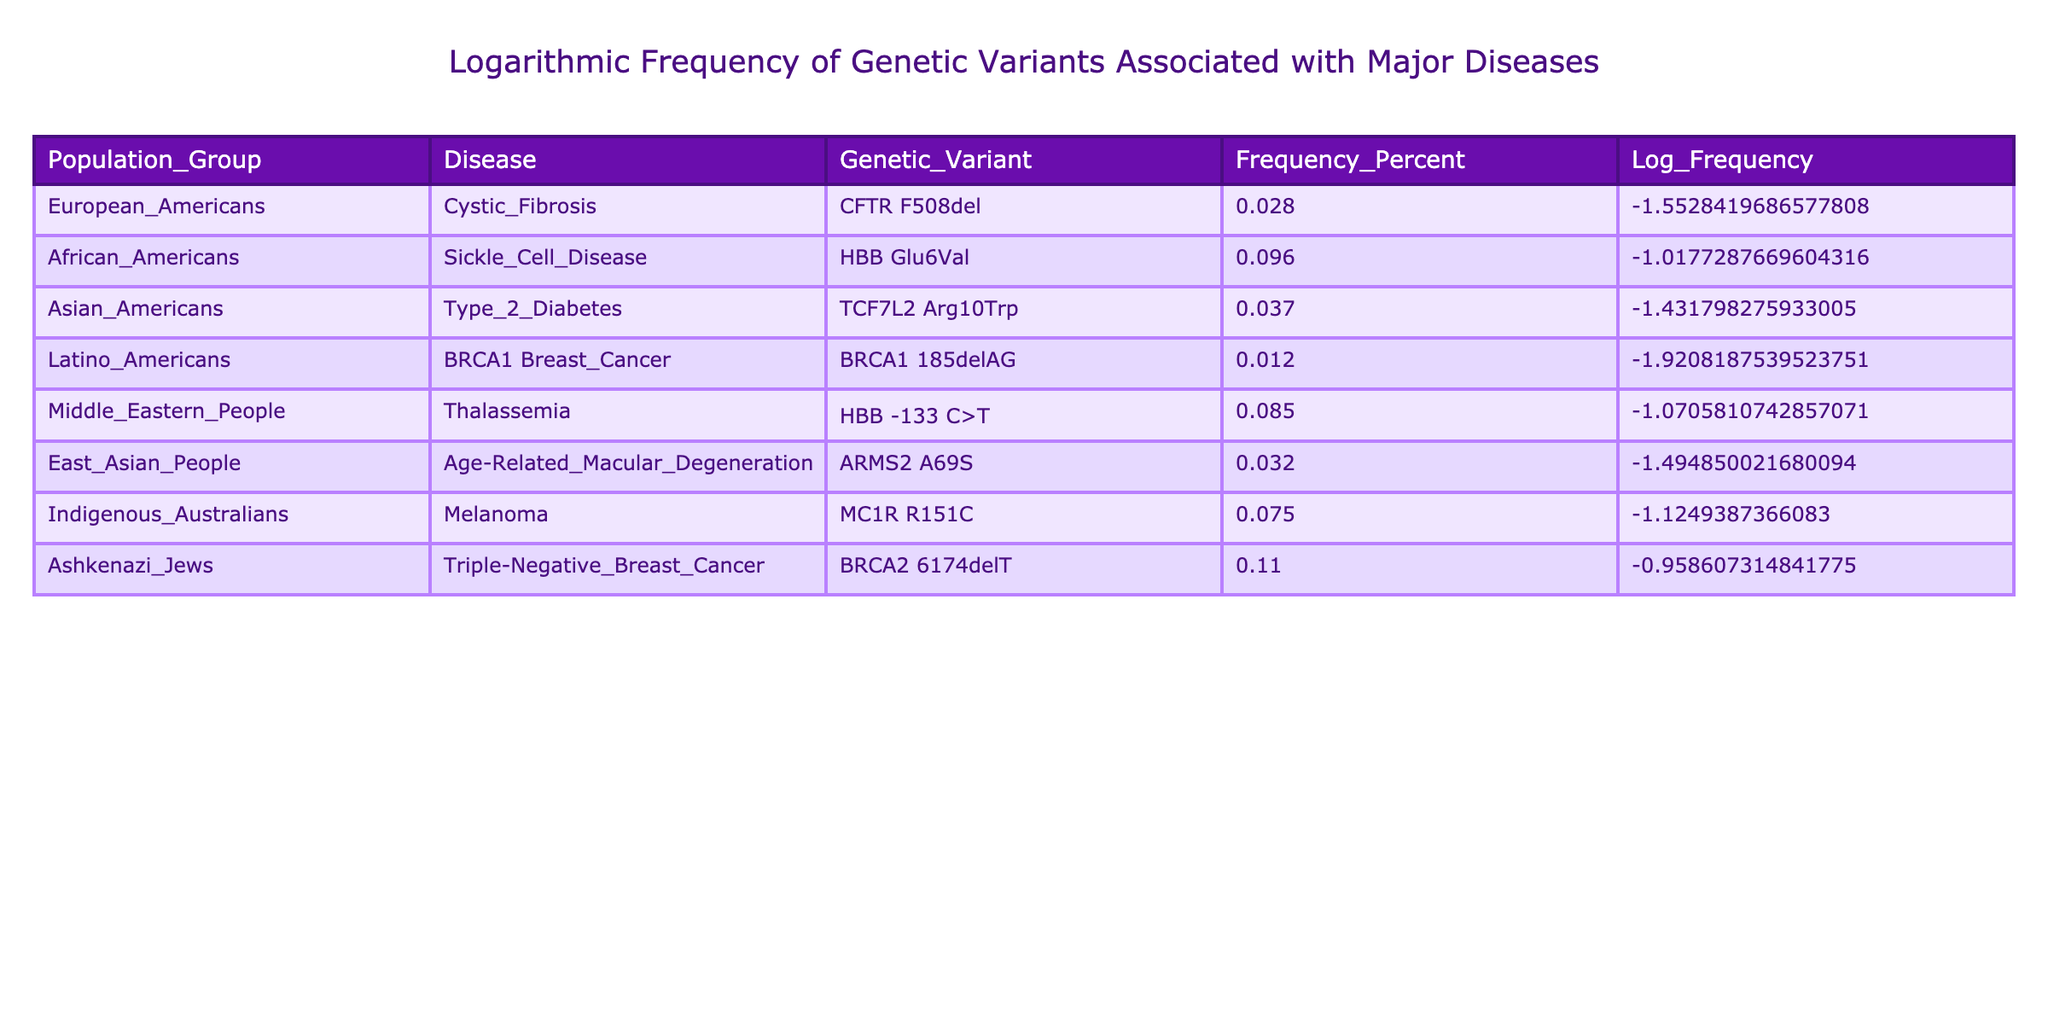What is the frequency of the CFTR F508del genetic variant in European Americans? The table shows that the frequency percent for the CFTR F508del variant in European Americans is listed directly as 0.028.
Answer: 0.028 Which disease has the highest frequency associated with a genetic variant among the listed population groups? By reviewing the frequency percent values in the table, the BRCA2 6174delT variant for Ashkenazi Jews has the highest frequency at 0.11.
Answer: BRCA2 6174delT What is the average frequency of the genetic variants for diseases in African Americans and Middle Eastern people? To find the average, we take the frequencies of the respective variants: 0.096 (for Sickle Cell Disease in African Americans) and 0.085 (for Thalassemia in Middle Eastern People). The sum is 0.096 + 0.085 = 0.181. Now, dividing by 2 gives 0.181 / 2 = 0.0905.
Answer: 0.0905 Is the frequency of TCF7L2 Arg10Trp variant higher in Asian Americans compared to the BRCA1 185delAG variant in Latino Americans? The frequency for TCF7L2 Arg10Trp in Asian Americans is 0.037, while for BRCA1 185delAG in Latino Americans, it is 0.012. Since 0.037 is greater than 0.012, the statement is true.
Answer: Yes What is the combined frequency of the genetic variants associated with Cystic Fibrosis and Age-Related Macular Degeneration for their respective population groups? The frequency of the CFTR F508del variant in European Americans is 0.028, while the frequency of ARMS2 A69S in East Asian People is 0.032. Adding these frequencies, we get 0.028 + 0.032 = 0.060.
Answer: 0.060 Does Sickle Cell Disease have a higher variant frequency among African Americans than Melanoma among Indigenous Australians? The frequency percent for Sickle Cell Disease (0.096) is higher than the frequency percent for Melanoma (0.075). Therefore, the statement is true.
Answer: Yes What is the total frequency of the genetic variants associated with the diseases listed for all U.S. population groups combined? To find the total frequency, we sum the frequencies of all listed variants: 0.028 + 0.096 + 0.037 + 0.012 + 0.085 + 0.032 + 0.075 + 0.11 = 0.475.
Answer: 0.475 Among all the diseases listed, which has the lowest frequency and what is that frequency? By examining the frequency values, the lowest frequency is 0.012 for the BRCA1 Breast Cancer variant in Latino Americans.
Answer: 0.012 